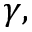<formula> <loc_0><loc_0><loc_500><loc_500>\gamma ,</formula> 